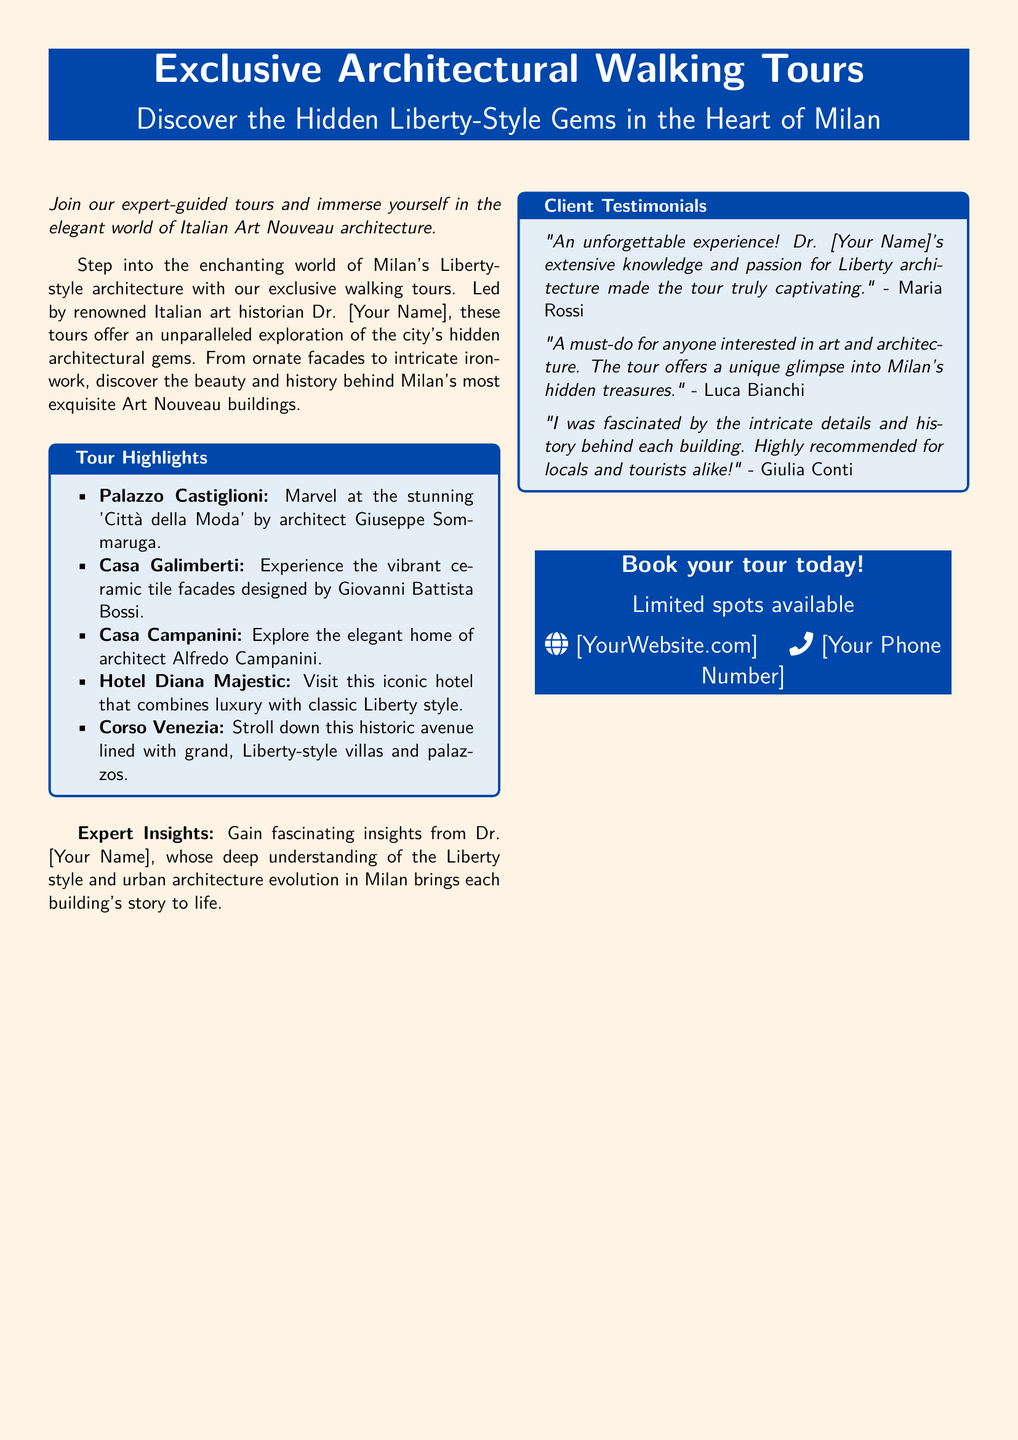What is the name of the tour guide? The tour guide is referred to as Dr. [Your Name] in the document.
Answer: Dr. [Your Name] What architectural style is the focus of the tours? The tours highlight Italian Art Nouveau architecture, specifically the Liberty style.
Answer: Liberty style How many tour highlights are mentioned in the document? There are five specific architectural highlights listed in the Highlights section.
Answer: 5 What is the contact method provided for booking? The document suggests contacting through a website and a phone number as methods for booking the tour.
Answer: [YourWebsite.com], [Your Phone Number] Who provided a testimonial praising the tour? The testimonial is given by Maria Rossi, who highlights the captivating nature of the tour.
Answer: Maria Rossi Which hotel is included in the tour highlights? The iconic hotel mentioned in the tour highlights is Hotel Diana Majestic.
Answer: Hotel Diana Majestic What is the color theme used in the advertisement? The advertisement primarily features a light gold background with blue accents.
Answer: Light gold, blue What type of experience does the tour promise? The tour promises an expert-guided exploration of hidden Liberty-style architectural gems.
Answer: Expert-guided exploration What kind of insights can participants expect? Participants can expect fascinating insights related to the Liberty style and urban architecture evolution.
Answer: Fascinating insights 